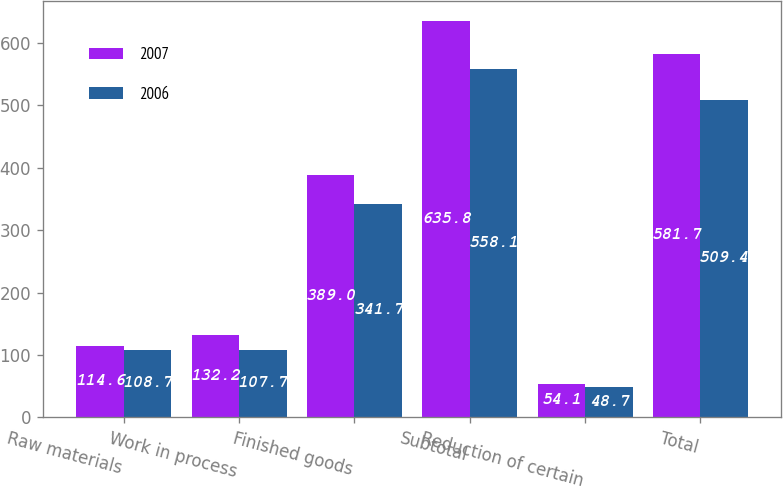Convert chart to OTSL. <chart><loc_0><loc_0><loc_500><loc_500><stacked_bar_chart><ecel><fcel>Raw materials<fcel>Work in process<fcel>Finished goods<fcel>Subtotal<fcel>Reduction of certain<fcel>Total<nl><fcel>2007<fcel>114.6<fcel>132.2<fcel>389<fcel>635.8<fcel>54.1<fcel>581.7<nl><fcel>2006<fcel>108.7<fcel>107.7<fcel>341.7<fcel>558.1<fcel>48.7<fcel>509.4<nl></chart> 